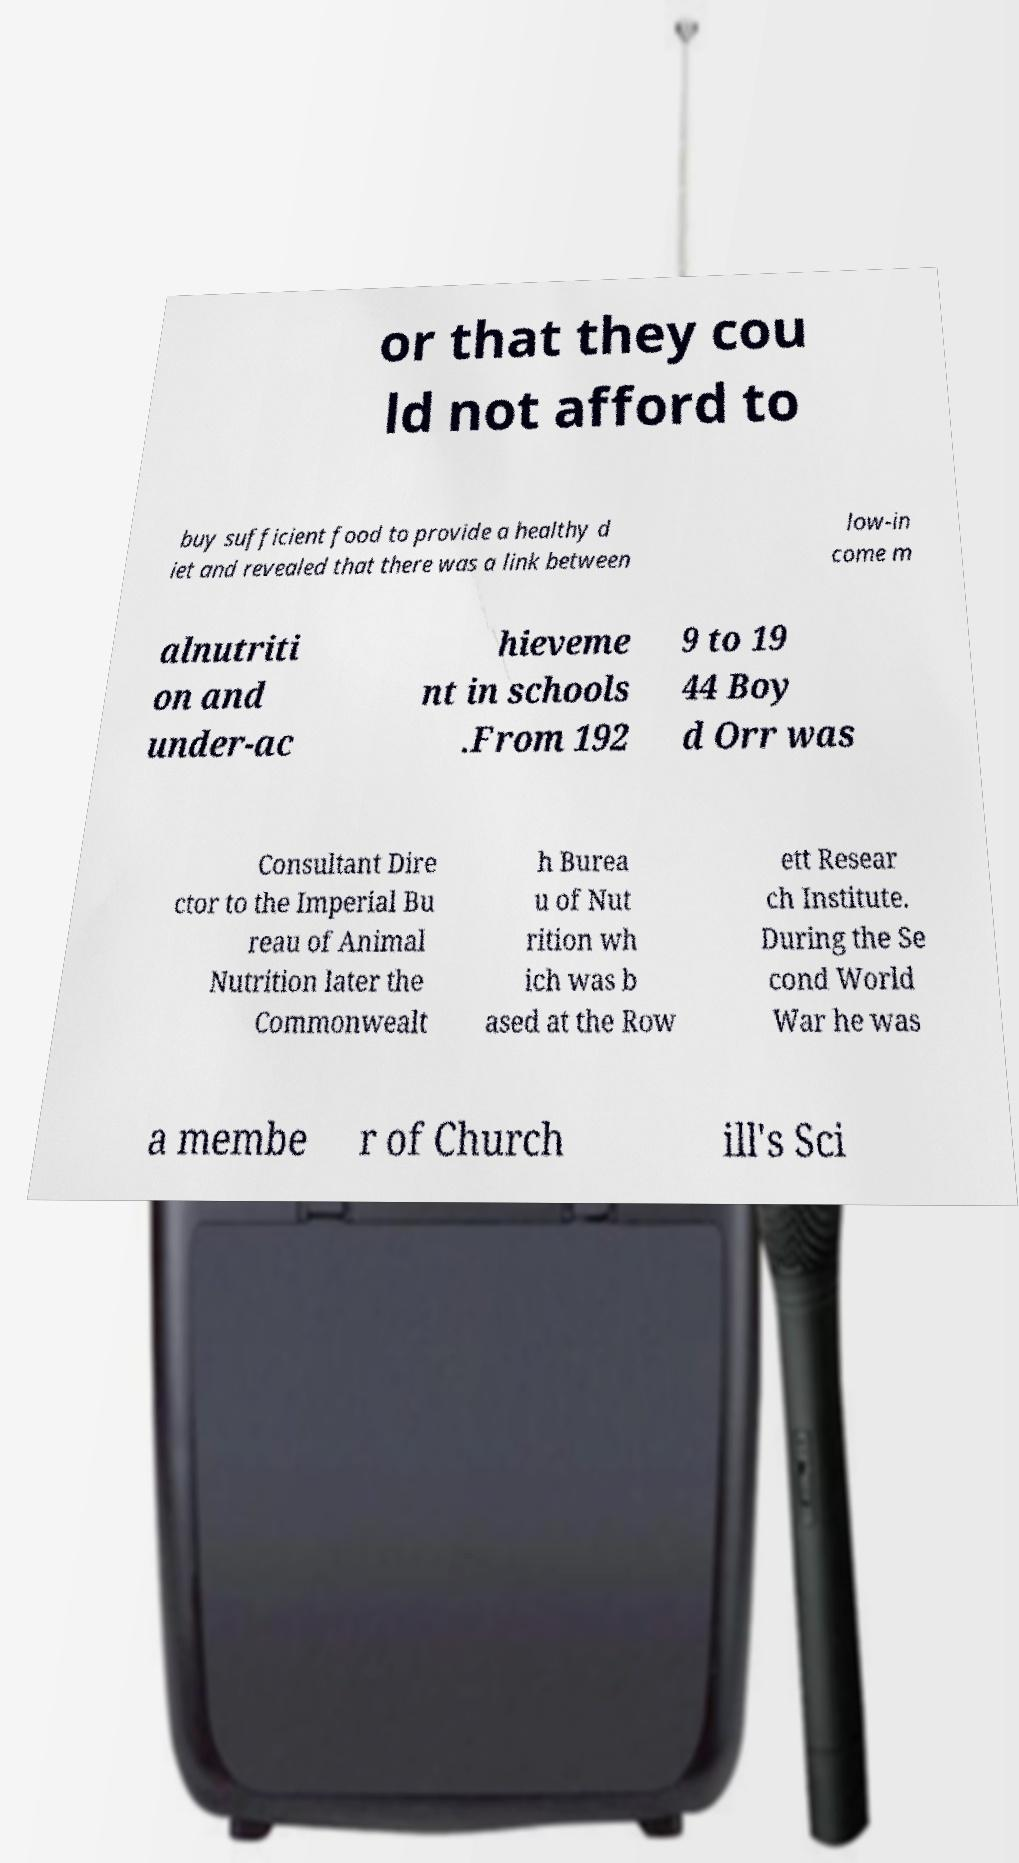There's text embedded in this image that I need extracted. Can you transcribe it verbatim? or that they cou ld not afford to buy sufficient food to provide a healthy d iet and revealed that there was a link between low-in come m alnutriti on and under-ac hieveme nt in schools .From 192 9 to 19 44 Boy d Orr was Consultant Dire ctor to the Imperial Bu reau of Animal Nutrition later the Commonwealt h Burea u of Nut rition wh ich was b ased at the Row ett Resear ch Institute. During the Se cond World War he was a membe r of Church ill's Sci 